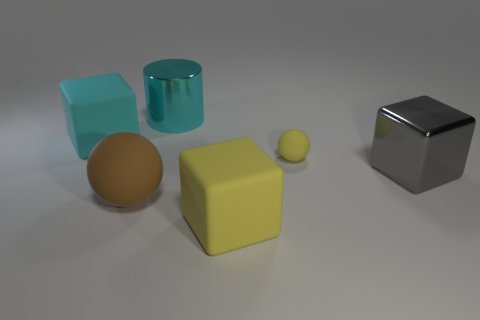Add 2 small gray cubes. How many objects exist? 8 Subtract all cylinders. How many objects are left? 5 Subtract 0 blue cylinders. How many objects are left? 6 Subtract all cyan shiny cylinders. Subtract all tiny matte things. How many objects are left? 4 Add 1 big cyan objects. How many big cyan objects are left? 3 Add 1 big green shiny cylinders. How many big green shiny cylinders exist? 1 